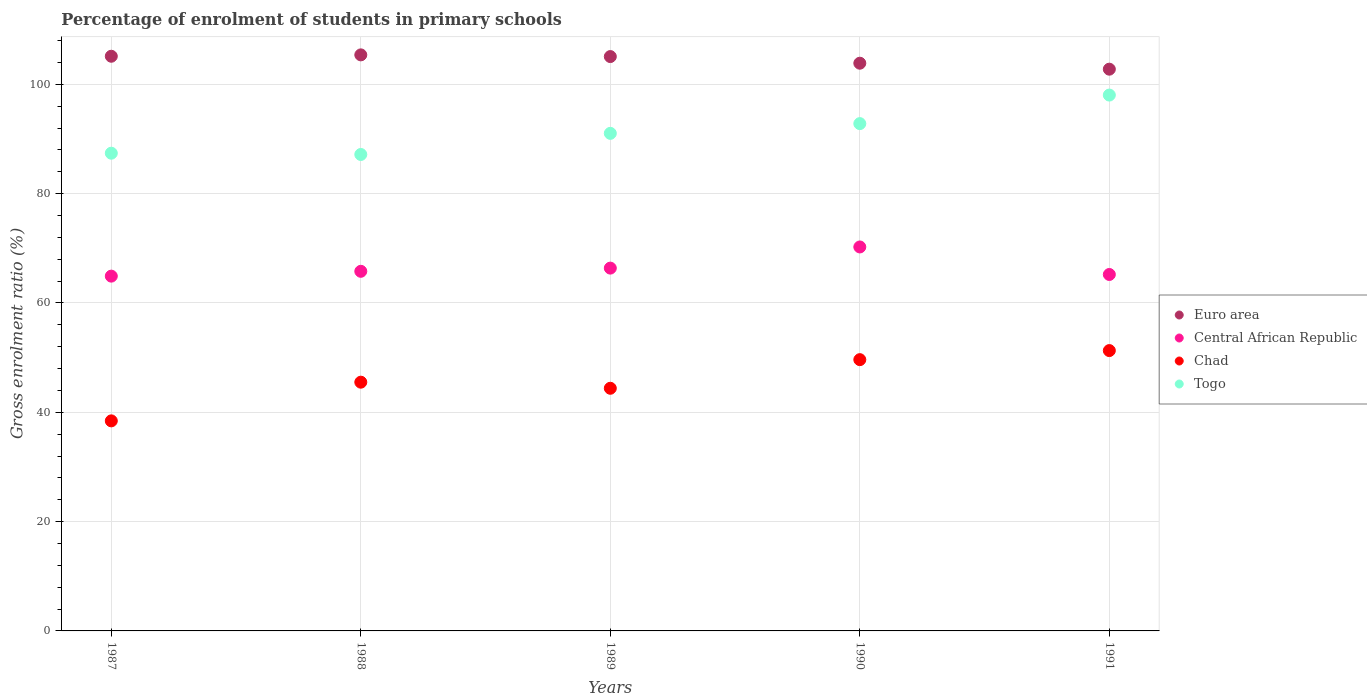How many different coloured dotlines are there?
Offer a very short reply. 4. Is the number of dotlines equal to the number of legend labels?
Offer a very short reply. Yes. What is the percentage of students enrolled in primary schools in Chad in 1991?
Your response must be concise. 51.29. Across all years, what is the maximum percentage of students enrolled in primary schools in Euro area?
Keep it short and to the point. 105.4. Across all years, what is the minimum percentage of students enrolled in primary schools in Central African Republic?
Offer a terse response. 64.91. In which year was the percentage of students enrolled in primary schools in Euro area maximum?
Provide a short and direct response. 1988. In which year was the percentage of students enrolled in primary schools in Euro area minimum?
Keep it short and to the point. 1991. What is the total percentage of students enrolled in primary schools in Euro area in the graph?
Offer a very short reply. 522.28. What is the difference between the percentage of students enrolled in primary schools in Central African Republic in 1989 and that in 1990?
Offer a very short reply. -3.87. What is the difference between the percentage of students enrolled in primary schools in Togo in 1991 and the percentage of students enrolled in primary schools in Euro area in 1989?
Make the answer very short. -7.04. What is the average percentage of students enrolled in primary schools in Euro area per year?
Give a very brief answer. 104.46. In the year 1988, what is the difference between the percentage of students enrolled in primary schools in Central African Republic and percentage of students enrolled in primary schools in Togo?
Offer a terse response. -21.38. What is the ratio of the percentage of students enrolled in primary schools in Chad in 1988 to that in 1989?
Offer a terse response. 1.03. Is the difference between the percentage of students enrolled in primary schools in Central African Republic in 1989 and 1990 greater than the difference between the percentage of students enrolled in primary schools in Togo in 1989 and 1990?
Offer a terse response. No. What is the difference between the highest and the second highest percentage of students enrolled in primary schools in Central African Republic?
Provide a succinct answer. 3.87. What is the difference between the highest and the lowest percentage of students enrolled in primary schools in Central African Republic?
Ensure brevity in your answer.  5.34. Is the sum of the percentage of students enrolled in primary schools in Central African Republic in 1990 and 1991 greater than the maximum percentage of students enrolled in primary schools in Togo across all years?
Your answer should be very brief. Yes. Is it the case that in every year, the sum of the percentage of students enrolled in primary schools in Togo and percentage of students enrolled in primary schools in Central African Republic  is greater than the sum of percentage of students enrolled in primary schools in Euro area and percentage of students enrolled in primary schools in Chad?
Make the answer very short. No. Does the percentage of students enrolled in primary schools in Euro area monotonically increase over the years?
Offer a very short reply. No. Is the percentage of students enrolled in primary schools in Central African Republic strictly less than the percentage of students enrolled in primary schools in Togo over the years?
Keep it short and to the point. Yes. How many dotlines are there?
Offer a very short reply. 4. What is the difference between two consecutive major ticks on the Y-axis?
Provide a short and direct response. 20. Does the graph contain any zero values?
Offer a terse response. No. How many legend labels are there?
Give a very brief answer. 4. How are the legend labels stacked?
Your answer should be very brief. Vertical. What is the title of the graph?
Ensure brevity in your answer.  Percentage of enrolment of students in primary schools. What is the label or title of the Y-axis?
Make the answer very short. Gross enrolment ratio (%). What is the Gross enrolment ratio (%) in Euro area in 1987?
Offer a terse response. 105.14. What is the Gross enrolment ratio (%) in Central African Republic in 1987?
Ensure brevity in your answer.  64.91. What is the Gross enrolment ratio (%) of Chad in 1987?
Your answer should be very brief. 38.43. What is the Gross enrolment ratio (%) in Togo in 1987?
Make the answer very short. 87.41. What is the Gross enrolment ratio (%) of Euro area in 1988?
Make the answer very short. 105.4. What is the Gross enrolment ratio (%) in Central African Republic in 1988?
Offer a terse response. 65.8. What is the Gross enrolment ratio (%) in Chad in 1988?
Provide a short and direct response. 45.51. What is the Gross enrolment ratio (%) of Togo in 1988?
Your answer should be very brief. 87.17. What is the Gross enrolment ratio (%) in Euro area in 1989?
Your answer should be compact. 105.09. What is the Gross enrolment ratio (%) in Central African Republic in 1989?
Make the answer very short. 66.38. What is the Gross enrolment ratio (%) of Chad in 1989?
Give a very brief answer. 44.4. What is the Gross enrolment ratio (%) in Togo in 1989?
Your answer should be compact. 91.04. What is the Gross enrolment ratio (%) in Euro area in 1990?
Provide a short and direct response. 103.87. What is the Gross enrolment ratio (%) in Central African Republic in 1990?
Offer a terse response. 70.25. What is the Gross enrolment ratio (%) of Chad in 1990?
Your answer should be compact. 49.63. What is the Gross enrolment ratio (%) in Togo in 1990?
Make the answer very short. 92.82. What is the Gross enrolment ratio (%) in Euro area in 1991?
Your response must be concise. 102.78. What is the Gross enrolment ratio (%) in Central African Republic in 1991?
Your answer should be very brief. 65.22. What is the Gross enrolment ratio (%) of Chad in 1991?
Ensure brevity in your answer.  51.29. What is the Gross enrolment ratio (%) of Togo in 1991?
Offer a terse response. 98.04. Across all years, what is the maximum Gross enrolment ratio (%) of Euro area?
Offer a terse response. 105.4. Across all years, what is the maximum Gross enrolment ratio (%) of Central African Republic?
Keep it short and to the point. 70.25. Across all years, what is the maximum Gross enrolment ratio (%) in Chad?
Provide a short and direct response. 51.29. Across all years, what is the maximum Gross enrolment ratio (%) of Togo?
Ensure brevity in your answer.  98.04. Across all years, what is the minimum Gross enrolment ratio (%) in Euro area?
Your answer should be compact. 102.78. Across all years, what is the minimum Gross enrolment ratio (%) in Central African Republic?
Ensure brevity in your answer.  64.91. Across all years, what is the minimum Gross enrolment ratio (%) of Chad?
Your response must be concise. 38.43. Across all years, what is the minimum Gross enrolment ratio (%) of Togo?
Provide a succinct answer. 87.17. What is the total Gross enrolment ratio (%) of Euro area in the graph?
Make the answer very short. 522.28. What is the total Gross enrolment ratio (%) in Central African Republic in the graph?
Provide a short and direct response. 332.56. What is the total Gross enrolment ratio (%) of Chad in the graph?
Your answer should be compact. 229.26. What is the total Gross enrolment ratio (%) in Togo in the graph?
Offer a very short reply. 456.48. What is the difference between the Gross enrolment ratio (%) of Euro area in 1987 and that in 1988?
Your answer should be compact. -0.25. What is the difference between the Gross enrolment ratio (%) of Central African Republic in 1987 and that in 1988?
Your answer should be compact. -0.88. What is the difference between the Gross enrolment ratio (%) in Chad in 1987 and that in 1988?
Provide a short and direct response. -7.08. What is the difference between the Gross enrolment ratio (%) in Togo in 1987 and that in 1988?
Keep it short and to the point. 0.23. What is the difference between the Gross enrolment ratio (%) in Euro area in 1987 and that in 1989?
Provide a short and direct response. 0.06. What is the difference between the Gross enrolment ratio (%) in Central African Republic in 1987 and that in 1989?
Your answer should be compact. -1.47. What is the difference between the Gross enrolment ratio (%) of Chad in 1987 and that in 1989?
Provide a succinct answer. -5.96. What is the difference between the Gross enrolment ratio (%) of Togo in 1987 and that in 1989?
Your answer should be compact. -3.63. What is the difference between the Gross enrolment ratio (%) in Euro area in 1987 and that in 1990?
Provide a short and direct response. 1.27. What is the difference between the Gross enrolment ratio (%) of Central African Republic in 1987 and that in 1990?
Keep it short and to the point. -5.34. What is the difference between the Gross enrolment ratio (%) of Chad in 1987 and that in 1990?
Keep it short and to the point. -11.2. What is the difference between the Gross enrolment ratio (%) of Togo in 1987 and that in 1990?
Give a very brief answer. -5.41. What is the difference between the Gross enrolment ratio (%) in Euro area in 1987 and that in 1991?
Ensure brevity in your answer.  2.37. What is the difference between the Gross enrolment ratio (%) of Central African Republic in 1987 and that in 1991?
Provide a short and direct response. -0.3. What is the difference between the Gross enrolment ratio (%) of Chad in 1987 and that in 1991?
Keep it short and to the point. -12.86. What is the difference between the Gross enrolment ratio (%) of Togo in 1987 and that in 1991?
Your answer should be very brief. -10.64. What is the difference between the Gross enrolment ratio (%) in Euro area in 1988 and that in 1989?
Offer a very short reply. 0.31. What is the difference between the Gross enrolment ratio (%) of Central African Republic in 1988 and that in 1989?
Your answer should be compact. -0.58. What is the difference between the Gross enrolment ratio (%) of Chad in 1988 and that in 1989?
Your answer should be very brief. 1.11. What is the difference between the Gross enrolment ratio (%) in Togo in 1988 and that in 1989?
Offer a very short reply. -3.87. What is the difference between the Gross enrolment ratio (%) of Euro area in 1988 and that in 1990?
Offer a terse response. 1.52. What is the difference between the Gross enrolment ratio (%) of Central African Republic in 1988 and that in 1990?
Give a very brief answer. -4.45. What is the difference between the Gross enrolment ratio (%) in Chad in 1988 and that in 1990?
Your answer should be compact. -4.12. What is the difference between the Gross enrolment ratio (%) in Togo in 1988 and that in 1990?
Offer a terse response. -5.65. What is the difference between the Gross enrolment ratio (%) of Euro area in 1988 and that in 1991?
Your response must be concise. 2.62. What is the difference between the Gross enrolment ratio (%) of Central African Republic in 1988 and that in 1991?
Make the answer very short. 0.58. What is the difference between the Gross enrolment ratio (%) in Chad in 1988 and that in 1991?
Your response must be concise. -5.78. What is the difference between the Gross enrolment ratio (%) in Togo in 1988 and that in 1991?
Provide a succinct answer. -10.87. What is the difference between the Gross enrolment ratio (%) of Euro area in 1989 and that in 1990?
Give a very brief answer. 1.21. What is the difference between the Gross enrolment ratio (%) of Central African Republic in 1989 and that in 1990?
Offer a very short reply. -3.87. What is the difference between the Gross enrolment ratio (%) in Chad in 1989 and that in 1990?
Your answer should be compact. -5.24. What is the difference between the Gross enrolment ratio (%) in Togo in 1989 and that in 1990?
Offer a very short reply. -1.78. What is the difference between the Gross enrolment ratio (%) of Euro area in 1989 and that in 1991?
Offer a very short reply. 2.31. What is the difference between the Gross enrolment ratio (%) in Central African Republic in 1989 and that in 1991?
Your response must be concise. 1.17. What is the difference between the Gross enrolment ratio (%) of Chad in 1989 and that in 1991?
Offer a terse response. -6.9. What is the difference between the Gross enrolment ratio (%) of Togo in 1989 and that in 1991?
Offer a terse response. -7. What is the difference between the Gross enrolment ratio (%) in Euro area in 1990 and that in 1991?
Make the answer very short. 1.09. What is the difference between the Gross enrolment ratio (%) of Central African Republic in 1990 and that in 1991?
Offer a very short reply. 5.04. What is the difference between the Gross enrolment ratio (%) in Chad in 1990 and that in 1991?
Ensure brevity in your answer.  -1.66. What is the difference between the Gross enrolment ratio (%) in Togo in 1990 and that in 1991?
Offer a terse response. -5.22. What is the difference between the Gross enrolment ratio (%) in Euro area in 1987 and the Gross enrolment ratio (%) in Central African Republic in 1988?
Ensure brevity in your answer.  39.35. What is the difference between the Gross enrolment ratio (%) of Euro area in 1987 and the Gross enrolment ratio (%) of Chad in 1988?
Keep it short and to the point. 59.63. What is the difference between the Gross enrolment ratio (%) in Euro area in 1987 and the Gross enrolment ratio (%) in Togo in 1988?
Provide a succinct answer. 17.97. What is the difference between the Gross enrolment ratio (%) of Central African Republic in 1987 and the Gross enrolment ratio (%) of Chad in 1988?
Your answer should be very brief. 19.4. What is the difference between the Gross enrolment ratio (%) in Central African Republic in 1987 and the Gross enrolment ratio (%) in Togo in 1988?
Make the answer very short. -22.26. What is the difference between the Gross enrolment ratio (%) in Chad in 1987 and the Gross enrolment ratio (%) in Togo in 1988?
Keep it short and to the point. -48.74. What is the difference between the Gross enrolment ratio (%) of Euro area in 1987 and the Gross enrolment ratio (%) of Central African Republic in 1989?
Offer a very short reply. 38.76. What is the difference between the Gross enrolment ratio (%) in Euro area in 1987 and the Gross enrolment ratio (%) in Chad in 1989?
Your answer should be compact. 60.75. What is the difference between the Gross enrolment ratio (%) in Euro area in 1987 and the Gross enrolment ratio (%) in Togo in 1989?
Provide a short and direct response. 14.11. What is the difference between the Gross enrolment ratio (%) of Central African Republic in 1987 and the Gross enrolment ratio (%) of Chad in 1989?
Your answer should be very brief. 20.52. What is the difference between the Gross enrolment ratio (%) in Central African Republic in 1987 and the Gross enrolment ratio (%) in Togo in 1989?
Your response must be concise. -26.12. What is the difference between the Gross enrolment ratio (%) in Chad in 1987 and the Gross enrolment ratio (%) in Togo in 1989?
Give a very brief answer. -52.61. What is the difference between the Gross enrolment ratio (%) in Euro area in 1987 and the Gross enrolment ratio (%) in Central African Republic in 1990?
Keep it short and to the point. 34.89. What is the difference between the Gross enrolment ratio (%) in Euro area in 1987 and the Gross enrolment ratio (%) in Chad in 1990?
Provide a succinct answer. 55.51. What is the difference between the Gross enrolment ratio (%) of Euro area in 1987 and the Gross enrolment ratio (%) of Togo in 1990?
Make the answer very short. 12.32. What is the difference between the Gross enrolment ratio (%) in Central African Republic in 1987 and the Gross enrolment ratio (%) in Chad in 1990?
Give a very brief answer. 15.28. What is the difference between the Gross enrolment ratio (%) of Central African Republic in 1987 and the Gross enrolment ratio (%) of Togo in 1990?
Your answer should be compact. -27.91. What is the difference between the Gross enrolment ratio (%) in Chad in 1987 and the Gross enrolment ratio (%) in Togo in 1990?
Offer a terse response. -54.39. What is the difference between the Gross enrolment ratio (%) in Euro area in 1987 and the Gross enrolment ratio (%) in Central African Republic in 1991?
Make the answer very short. 39.93. What is the difference between the Gross enrolment ratio (%) in Euro area in 1987 and the Gross enrolment ratio (%) in Chad in 1991?
Offer a very short reply. 53.85. What is the difference between the Gross enrolment ratio (%) in Euro area in 1987 and the Gross enrolment ratio (%) in Togo in 1991?
Your response must be concise. 7.1. What is the difference between the Gross enrolment ratio (%) in Central African Republic in 1987 and the Gross enrolment ratio (%) in Chad in 1991?
Provide a short and direct response. 13.62. What is the difference between the Gross enrolment ratio (%) in Central African Republic in 1987 and the Gross enrolment ratio (%) in Togo in 1991?
Your response must be concise. -33.13. What is the difference between the Gross enrolment ratio (%) of Chad in 1987 and the Gross enrolment ratio (%) of Togo in 1991?
Offer a terse response. -59.61. What is the difference between the Gross enrolment ratio (%) in Euro area in 1988 and the Gross enrolment ratio (%) in Central African Republic in 1989?
Make the answer very short. 39.01. What is the difference between the Gross enrolment ratio (%) of Euro area in 1988 and the Gross enrolment ratio (%) of Chad in 1989?
Your answer should be compact. 61. What is the difference between the Gross enrolment ratio (%) in Euro area in 1988 and the Gross enrolment ratio (%) in Togo in 1989?
Your answer should be compact. 14.36. What is the difference between the Gross enrolment ratio (%) in Central African Republic in 1988 and the Gross enrolment ratio (%) in Chad in 1989?
Your answer should be compact. 21.4. What is the difference between the Gross enrolment ratio (%) in Central African Republic in 1988 and the Gross enrolment ratio (%) in Togo in 1989?
Make the answer very short. -25.24. What is the difference between the Gross enrolment ratio (%) of Chad in 1988 and the Gross enrolment ratio (%) of Togo in 1989?
Your answer should be compact. -45.53. What is the difference between the Gross enrolment ratio (%) in Euro area in 1988 and the Gross enrolment ratio (%) in Central African Republic in 1990?
Make the answer very short. 35.15. What is the difference between the Gross enrolment ratio (%) in Euro area in 1988 and the Gross enrolment ratio (%) in Chad in 1990?
Keep it short and to the point. 55.76. What is the difference between the Gross enrolment ratio (%) of Euro area in 1988 and the Gross enrolment ratio (%) of Togo in 1990?
Your response must be concise. 12.58. What is the difference between the Gross enrolment ratio (%) of Central African Republic in 1988 and the Gross enrolment ratio (%) of Chad in 1990?
Give a very brief answer. 16.16. What is the difference between the Gross enrolment ratio (%) of Central African Republic in 1988 and the Gross enrolment ratio (%) of Togo in 1990?
Offer a very short reply. -27.02. What is the difference between the Gross enrolment ratio (%) of Chad in 1988 and the Gross enrolment ratio (%) of Togo in 1990?
Your response must be concise. -47.31. What is the difference between the Gross enrolment ratio (%) in Euro area in 1988 and the Gross enrolment ratio (%) in Central African Republic in 1991?
Offer a terse response. 40.18. What is the difference between the Gross enrolment ratio (%) of Euro area in 1988 and the Gross enrolment ratio (%) of Chad in 1991?
Your answer should be compact. 54.1. What is the difference between the Gross enrolment ratio (%) in Euro area in 1988 and the Gross enrolment ratio (%) in Togo in 1991?
Offer a very short reply. 7.35. What is the difference between the Gross enrolment ratio (%) of Central African Republic in 1988 and the Gross enrolment ratio (%) of Chad in 1991?
Offer a terse response. 14.51. What is the difference between the Gross enrolment ratio (%) of Central African Republic in 1988 and the Gross enrolment ratio (%) of Togo in 1991?
Ensure brevity in your answer.  -32.25. What is the difference between the Gross enrolment ratio (%) of Chad in 1988 and the Gross enrolment ratio (%) of Togo in 1991?
Offer a very short reply. -52.53. What is the difference between the Gross enrolment ratio (%) in Euro area in 1989 and the Gross enrolment ratio (%) in Central African Republic in 1990?
Provide a succinct answer. 34.84. What is the difference between the Gross enrolment ratio (%) in Euro area in 1989 and the Gross enrolment ratio (%) in Chad in 1990?
Offer a terse response. 55.45. What is the difference between the Gross enrolment ratio (%) of Euro area in 1989 and the Gross enrolment ratio (%) of Togo in 1990?
Provide a succinct answer. 12.27. What is the difference between the Gross enrolment ratio (%) in Central African Republic in 1989 and the Gross enrolment ratio (%) in Chad in 1990?
Keep it short and to the point. 16.75. What is the difference between the Gross enrolment ratio (%) of Central African Republic in 1989 and the Gross enrolment ratio (%) of Togo in 1990?
Provide a succinct answer. -26.44. What is the difference between the Gross enrolment ratio (%) of Chad in 1989 and the Gross enrolment ratio (%) of Togo in 1990?
Provide a succinct answer. -48.42. What is the difference between the Gross enrolment ratio (%) of Euro area in 1989 and the Gross enrolment ratio (%) of Central African Republic in 1991?
Keep it short and to the point. 39.87. What is the difference between the Gross enrolment ratio (%) of Euro area in 1989 and the Gross enrolment ratio (%) of Chad in 1991?
Your answer should be very brief. 53.79. What is the difference between the Gross enrolment ratio (%) in Euro area in 1989 and the Gross enrolment ratio (%) in Togo in 1991?
Offer a very short reply. 7.04. What is the difference between the Gross enrolment ratio (%) in Central African Republic in 1989 and the Gross enrolment ratio (%) in Chad in 1991?
Keep it short and to the point. 15.09. What is the difference between the Gross enrolment ratio (%) of Central African Republic in 1989 and the Gross enrolment ratio (%) of Togo in 1991?
Your answer should be very brief. -31.66. What is the difference between the Gross enrolment ratio (%) of Chad in 1989 and the Gross enrolment ratio (%) of Togo in 1991?
Offer a very short reply. -53.65. What is the difference between the Gross enrolment ratio (%) of Euro area in 1990 and the Gross enrolment ratio (%) of Central African Republic in 1991?
Provide a short and direct response. 38.66. What is the difference between the Gross enrolment ratio (%) in Euro area in 1990 and the Gross enrolment ratio (%) in Chad in 1991?
Make the answer very short. 52.58. What is the difference between the Gross enrolment ratio (%) of Euro area in 1990 and the Gross enrolment ratio (%) of Togo in 1991?
Keep it short and to the point. 5.83. What is the difference between the Gross enrolment ratio (%) in Central African Republic in 1990 and the Gross enrolment ratio (%) in Chad in 1991?
Make the answer very short. 18.96. What is the difference between the Gross enrolment ratio (%) in Central African Republic in 1990 and the Gross enrolment ratio (%) in Togo in 1991?
Your response must be concise. -27.79. What is the difference between the Gross enrolment ratio (%) in Chad in 1990 and the Gross enrolment ratio (%) in Togo in 1991?
Give a very brief answer. -48.41. What is the average Gross enrolment ratio (%) of Euro area per year?
Your response must be concise. 104.46. What is the average Gross enrolment ratio (%) in Central African Republic per year?
Your response must be concise. 66.51. What is the average Gross enrolment ratio (%) in Chad per year?
Keep it short and to the point. 45.85. What is the average Gross enrolment ratio (%) in Togo per year?
Your response must be concise. 91.3. In the year 1987, what is the difference between the Gross enrolment ratio (%) of Euro area and Gross enrolment ratio (%) of Central African Republic?
Ensure brevity in your answer.  40.23. In the year 1987, what is the difference between the Gross enrolment ratio (%) of Euro area and Gross enrolment ratio (%) of Chad?
Your answer should be very brief. 66.71. In the year 1987, what is the difference between the Gross enrolment ratio (%) of Euro area and Gross enrolment ratio (%) of Togo?
Provide a succinct answer. 17.74. In the year 1987, what is the difference between the Gross enrolment ratio (%) in Central African Republic and Gross enrolment ratio (%) in Chad?
Offer a terse response. 26.48. In the year 1987, what is the difference between the Gross enrolment ratio (%) in Central African Republic and Gross enrolment ratio (%) in Togo?
Provide a succinct answer. -22.49. In the year 1987, what is the difference between the Gross enrolment ratio (%) of Chad and Gross enrolment ratio (%) of Togo?
Make the answer very short. -48.97. In the year 1988, what is the difference between the Gross enrolment ratio (%) of Euro area and Gross enrolment ratio (%) of Central African Republic?
Keep it short and to the point. 39.6. In the year 1988, what is the difference between the Gross enrolment ratio (%) of Euro area and Gross enrolment ratio (%) of Chad?
Offer a very short reply. 59.89. In the year 1988, what is the difference between the Gross enrolment ratio (%) in Euro area and Gross enrolment ratio (%) in Togo?
Keep it short and to the point. 18.22. In the year 1988, what is the difference between the Gross enrolment ratio (%) of Central African Republic and Gross enrolment ratio (%) of Chad?
Your answer should be compact. 20.29. In the year 1988, what is the difference between the Gross enrolment ratio (%) in Central African Republic and Gross enrolment ratio (%) in Togo?
Make the answer very short. -21.38. In the year 1988, what is the difference between the Gross enrolment ratio (%) in Chad and Gross enrolment ratio (%) in Togo?
Keep it short and to the point. -41.66. In the year 1989, what is the difference between the Gross enrolment ratio (%) of Euro area and Gross enrolment ratio (%) of Central African Republic?
Offer a terse response. 38.7. In the year 1989, what is the difference between the Gross enrolment ratio (%) of Euro area and Gross enrolment ratio (%) of Chad?
Make the answer very short. 60.69. In the year 1989, what is the difference between the Gross enrolment ratio (%) of Euro area and Gross enrolment ratio (%) of Togo?
Your answer should be very brief. 14.05. In the year 1989, what is the difference between the Gross enrolment ratio (%) in Central African Republic and Gross enrolment ratio (%) in Chad?
Provide a short and direct response. 21.99. In the year 1989, what is the difference between the Gross enrolment ratio (%) in Central African Republic and Gross enrolment ratio (%) in Togo?
Keep it short and to the point. -24.66. In the year 1989, what is the difference between the Gross enrolment ratio (%) of Chad and Gross enrolment ratio (%) of Togo?
Give a very brief answer. -46.64. In the year 1990, what is the difference between the Gross enrolment ratio (%) in Euro area and Gross enrolment ratio (%) in Central African Republic?
Your answer should be very brief. 33.62. In the year 1990, what is the difference between the Gross enrolment ratio (%) in Euro area and Gross enrolment ratio (%) in Chad?
Make the answer very short. 54.24. In the year 1990, what is the difference between the Gross enrolment ratio (%) in Euro area and Gross enrolment ratio (%) in Togo?
Your response must be concise. 11.05. In the year 1990, what is the difference between the Gross enrolment ratio (%) of Central African Republic and Gross enrolment ratio (%) of Chad?
Provide a succinct answer. 20.62. In the year 1990, what is the difference between the Gross enrolment ratio (%) of Central African Republic and Gross enrolment ratio (%) of Togo?
Keep it short and to the point. -22.57. In the year 1990, what is the difference between the Gross enrolment ratio (%) in Chad and Gross enrolment ratio (%) in Togo?
Keep it short and to the point. -43.19. In the year 1991, what is the difference between the Gross enrolment ratio (%) in Euro area and Gross enrolment ratio (%) in Central African Republic?
Offer a terse response. 37.56. In the year 1991, what is the difference between the Gross enrolment ratio (%) in Euro area and Gross enrolment ratio (%) in Chad?
Your answer should be compact. 51.49. In the year 1991, what is the difference between the Gross enrolment ratio (%) in Euro area and Gross enrolment ratio (%) in Togo?
Ensure brevity in your answer.  4.74. In the year 1991, what is the difference between the Gross enrolment ratio (%) in Central African Republic and Gross enrolment ratio (%) in Chad?
Your answer should be very brief. 13.92. In the year 1991, what is the difference between the Gross enrolment ratio (%) of Central African Republic and Gross enrolment ratio (%) of Togo?
Give a very brief answer. -32.83. In the year 1991, what is the difference between the Gross enrolment ratio (%) in Chad and Gross enrolment ratio (%) in Togo?
Your response must be concise. -46.75. What is the ratio of the Gross enrolment ratio (%) in Central African Republic in 1987 to that in 1988?
Offer a very short reply. 0.99. What is the ratio of the Gross enrolment ratio (%) of Chad in 1987 to that in 1988?
Give a very brief answer. 0.84. What is the ratio of the Gross enrolment ratio (%) in Euro area in 1987 to that in 1989?
Provide a short and direct response. 1. What is the ratio of the Gross enrolment ratio (%) in Central African Republic in 1987 to that in 1989?
Offer a very short reply. 0.98. What is the ratio of the Gross enrolment ratio (%) in Chad in 1987 to that in 1989?
Your answer should be very brief. 0.87. What is the ratio of the Gross enrolment ratio (%) of Togo in 1987 to that in 1989?
Provide a succinct answer. 0.96. What is the ratio of the Gross enrolment ratio (%) in Euro area in 1987 to that in 1990?
Provide a short and direct response. 1.01. What is the ratio of the Gross enrolment ratio (%) in Central African Republic in 1987 to that in 1990?
Provide a short and direct response. 0.92. What is the ratio of the Gross enrolment ratio (%) in Chad in 1987 to that in 1990?
Your answer should be compact. 0.77. What is the ratio of the Gross enrolment ratio (%) in Togo in 1987 to that in 1990?
Your answer should be very brief. 0.94. What is the ratio of the Gross enrolment ratio (%) of Euro area in 1987 to that in 1991?
Provide a succinct answer. 1.02. What is the ratio of the Gross enrolment ratio (%) of Chad in 1987 to that in 1991?
Ensure brevity in your answer.  0.75. What is the ratio of the Gross enrolment ratio (%) in Togo in 1987 to that in 1991?
Ensure brevity in your answer.  0.89. What is the ratio of the Gross enrolment ratio (%) in Euro area in 1988 to that in 1989?
Your answer should be compact. 1. What is the ratio of the Gross enrolment ratio (%) of Central African Republic in 1988 to that in 1989?
Provide a short and direct response. 0.99. What is the ratio of the Gross enrolment ratio (%) of Chad in 1988 to that in 1989?
Offer a very short reply. 1.03. What is the ratio of the Gross enrolment ratio (%) of Togo in 1988 to that in 1989?
Your response must be concise. 0.96. What is the ratio of the Gross enrolment ratio (%) of Euro area in 1988 to that in 1990?
Your answer should be compact. 1.01. What is the ratio of the Gross enrolment ratio (%) in Central African Republic in 1988 to that in 1990?
Your answer should be compact. 0.94. What is the ratio of the Gross enrolment ratio (%) of Chad in 1988 to that in 1990?
Provide a short and direct response. 0.92. What is the ratio of the Gross enrolment ratio (%) of Togo in 1988 to that in 1990?
Make the answer very short. 0.94. What is the ratio of the Gross enrolment ratio (%) in Euro area in 1988 to that in 1991?
Your answer should be compact. 1.03. What is the ratio of the Gross enrolment ratio (%) in Central African Republic in 1988 to that in 1991?
Provide a succinct answer. 1.01. What is the ratio of the Gross enrolment ratio (%) in Chad in 1988 to that in 1991?
Your response must be concise. 0.89. What is the ratio of the Gross enrolment ratio (%) in Togo in 1988 to that in 1991?
Provide a succinct answer. 0.89. What is the ratio of the Gross enrolment ratio (%) in Euro area in 1989 to that in 1990?
Your response must be concise. 1.01. What is the ratio of the Gross enrolment ratio (%) of Central African Republic in 1989 to that in 1990?
Offer a very short reply. 0.94. What is the ratio of the Gross enrolment ratio (%) in Chad in 1989 to that in 1990?
Keep it short and to the point. 0.89. What is the ratio of the Gross enrolment ratio (%) of Togo in 1989 to that in 1990?
Ensure brevity in your answer.  0.98. What is the ratio of the Gross enrolment ratio (%) of Euro area in 1989 to that in 1991?
Your answer should be compact. 1.02. What is the ratio of the Gross enrolment ratio (%) of Central African Republic in 1989 to that in 1991?
Ensure brevity in your answer.  1.02. What is the ratio of the Gross enrolment ratio (%) in Chad in 1989 to that in 1991?
Ensure brevity in your answer.  0.87. What is the ratio of the Gross enrolment ratio (%) in Euro area in 1990 to that in 1991?
Provide a short and direct response. 1.01. What is the ratio of the Gross enrolment ratio (%) in Central African Republic in 1990 to that in 1991?
Your response must be concise. 1.08. What is the ratio of the Gross enrolment ratio (%) of Togo in 1990 to that in 1991?
Make the answer very short. 0.95. What is the difference between the highest and the second highest Gross enrolment ratio (%) in Euro area?
Provide a short and direct response. 0.25. What is the difference between the highest and the second highest Gross enrolment ratio (%) in Central African Republic?
Keep it short and to the point. 3.87. What is the difference between the highest and the second highest Gross enrolment ratio (%) in Chad?
Make the answer very short. 1.66. What is the difference between the highest and the second highest Gross enrolment ratio (%) of Togo?
Your answer should be very brief. 5.22. What is the difference between the highest and the lowest Gross enrolment ratio (%) of Euro area?
Give a very brief answer. 2.62. What is the difference between the highest and the lowest Gross enrolment ratio (%) in Central African Republic?
Offer a terse response. 5.34. What is the difference between the highest and the lowest Gross enrolment ratio (%) in Chad?
Offer a very short reply. 12.86. What is the difference between the highest and the lowest Gross enrolment ratio (%) in Togo?
Offer a very short reply. 10.87. 